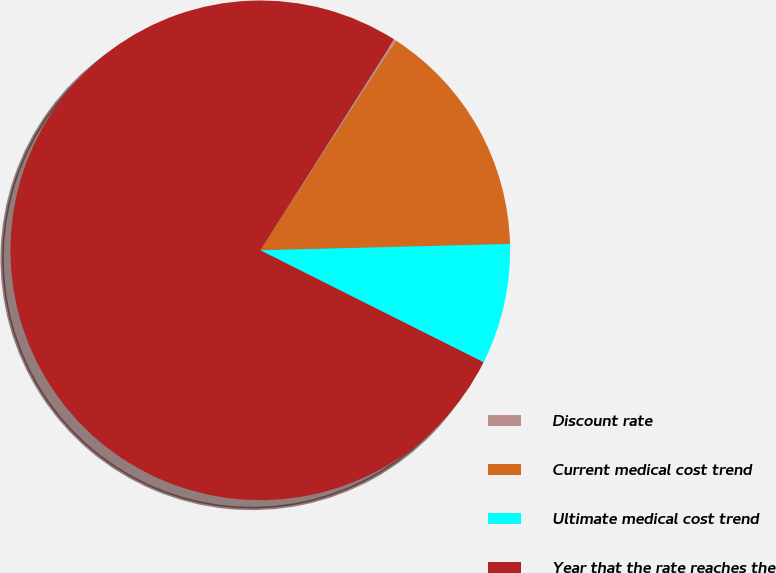Convert chart. <chart><loc_0><loc_0><loc_500><loc_500><pie_chart><fcel>Discount rate<fcel>Current medical cost trend<fcel>Ultimate medical cost trend<fcel>Year that the rate reaches the<nl><fcel>0.16%<fcel>15.45%<fcel>7.8%<fcel>76.59%<nl></chart> 